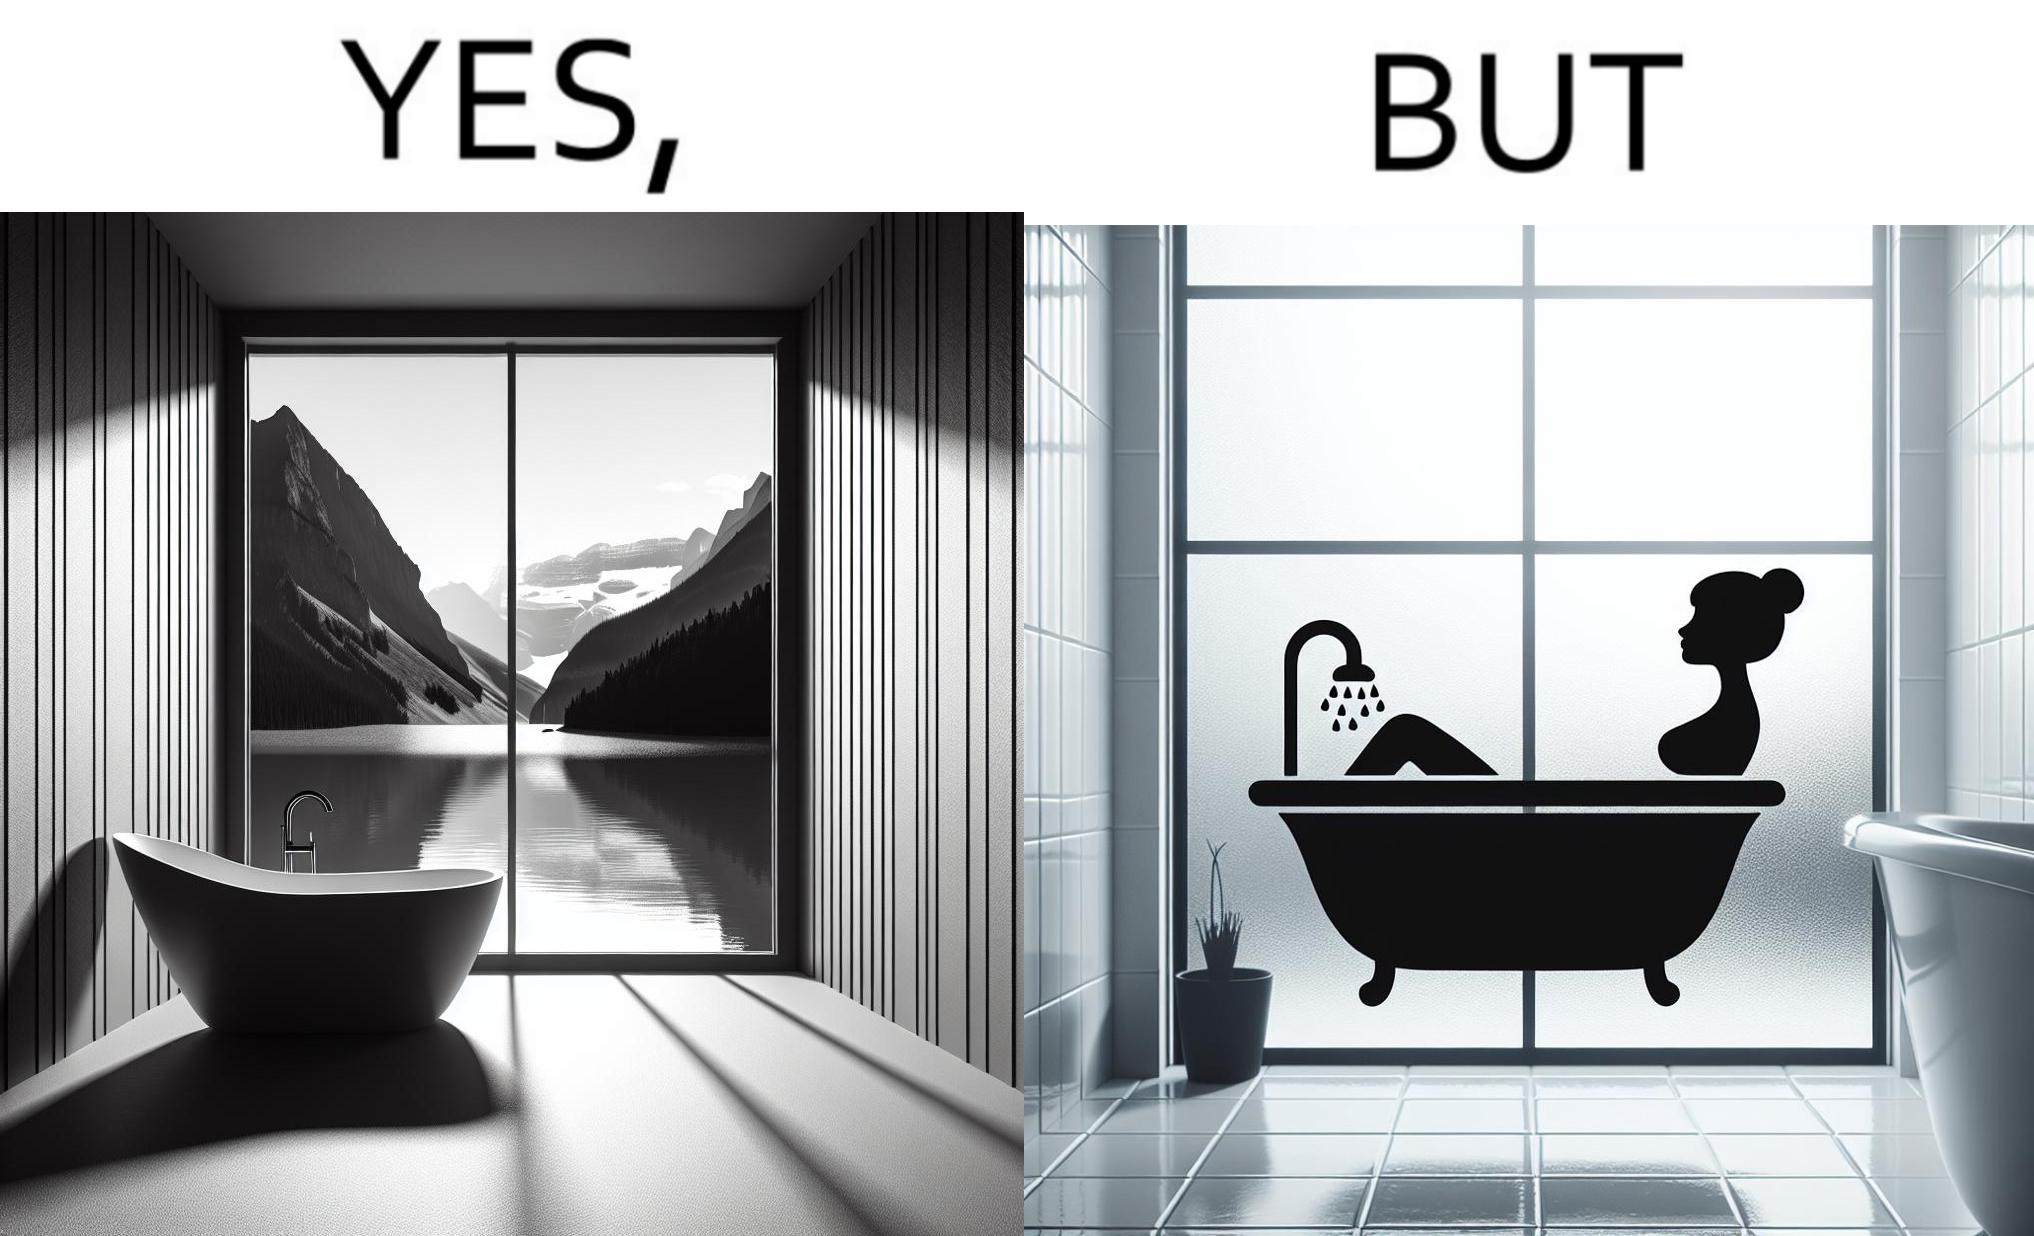Describe what you see in the left and right parts of this image. In the left part of the image: a bathtub by the side of a window which has a very scenic view of lake and mountains. In the right part of the image: a woman bathing in a bathtub, while the window glasses are foggy from the steam of the hot water. 